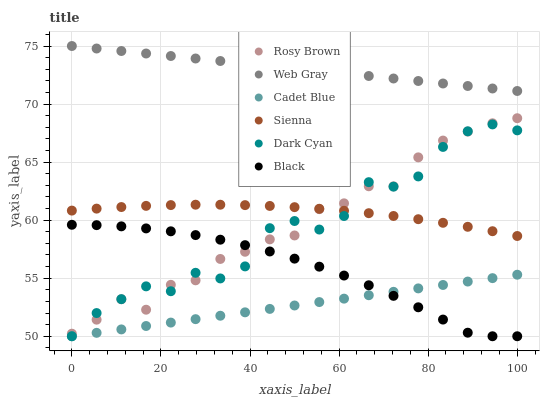Does Cadet Blue have the minimum area under the curve?
Answer yes or no. Yes. Does Web Gray have the maximum area under the curve?
Answer yes or no. Yes. Does Rosy Brown have the minimum area under the curve?
Answer yes or no. No. Does Rosy Brown have the maximum area under the curve?
Answer yes or no. No. Is Web Gray the smoothest?
Answer yes or no. Yes. Is Dark Cyan the roughest?
Answer yes or no. Yes. Is Rosy Brown the smoothest?
Answer yes or no. No. Is Rosy Brown the roughest?
Answer yes or no. No. Does Cadet Blue have the lowest value?
Answer yes or no. Yes. Does Rosy Brown have the lowest value?
Answer yes or no. No. Does Web Gray have the highest value?
Answer yes or no. Yes. Does Rosy Brown have the highest value?
Answer yes or no. No. Is Rosy Brown less than Web Gray?
Answer yes or no. Yes. Is Web Gray greater than Black?
Answer yes or no. Yes. Does Black intersect Dark Cyan?
Answer yes or no. Yes. Is Black less than Dark Cyan?
Answer yes or no. No. Is Black greater than Dark Cyan?
Answer yes or no. No. Does Rosy Brown intersect Web Gray?
Answer yes or no. No. 